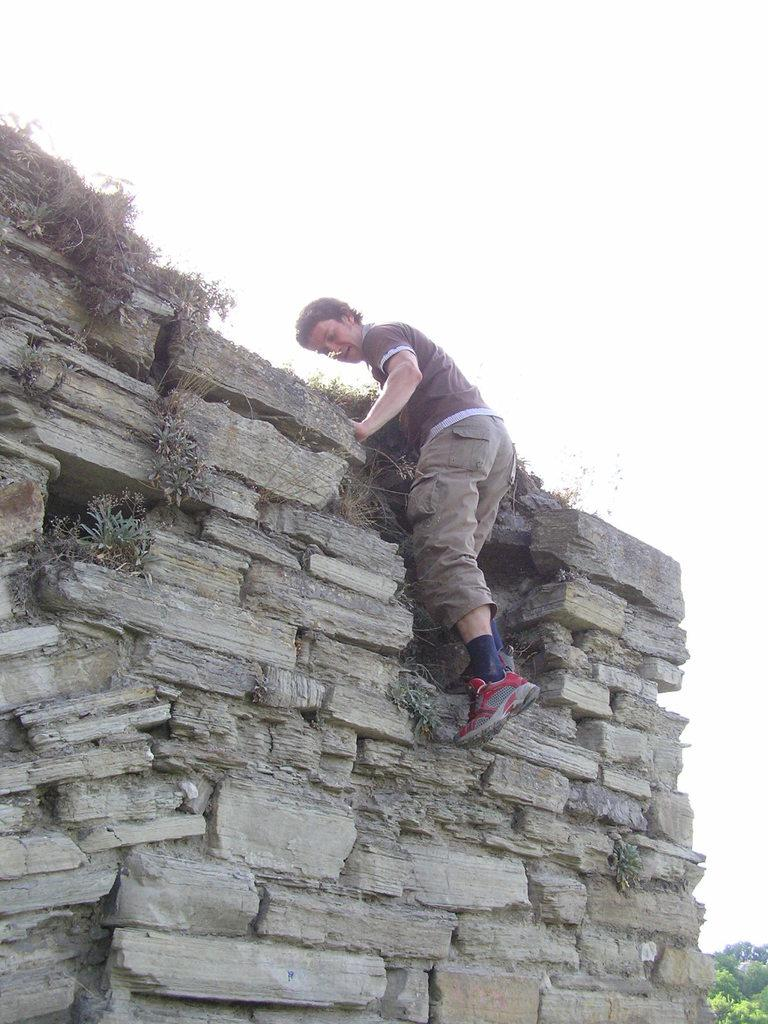What type of natural elements can be seen in the image? There are rocks and plants in the image. Can you describe the person in the image? There is a person in the image, but their appearance or actions are not specified. Where are the trees located in the image? The trees are on the right side bottom of the image. What is visible at the top of the image? The sky is visible at the top of the image. What type of drug is being sold by the person in the image? There is no indication in the image that a person is selling drugs or any other items. 